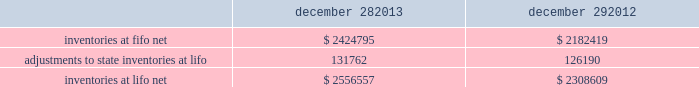Advance auto parts , inc .
And subsidiaries notes to the consolidated financial statements december 28 , 2013 , december 29 , 2012 and december 31 , 2011 ( in thousands , except per share data ) in july 2012 , the fasb issued asu no .
2012-02 201cintangible-goodwill and other 2013 testing indefinite-lived intangible assets for impairment . 201d asu 2012-02 modifies the requirement to test intangible assets that are not subject to amortization based on events or changes in circumstances that might indicate that the asset is impaired now requiring the test only if it is more likely than not that the asset is impaired .
Furthermore , asu 2012-02 provides entities the option of performing a qualitative assessment to determine if it is more likely than not that the fair value of an intangible asset is less than the carrying amount as a basis for determining whether it is necessary to perform a quantitative impairment test .
Asu 2012-02 is effective for fiscal years beginning after september 15 , 2012 and early adoption is permitted .
The adoption of asu 2012-02 had no impact on the company 2019s consolidated financial condition , results of operations or cash flows .
Inventories , net : merchandise inventory the company used the lifo method of accounting for approximately 95% ( 95 % ) of inventories at both december 28 , 2013 and december 29 , 2012 .
Under lifo , the company 2019s cost of sales reflects the costs of the most recently purchased inventories , while the inventory carrying balance represents the costs for inventories purchased in fiscal 2013 and prior years .
The company recorded a reduction to cost of sales of $ 5572 and $ 24087 in fiscal 2013 and fiscal 2012 , respectively .
The company 2019s overall costs to acquire inventory for the same or similar products have generally decreased historically as the company has been able to leverage its continued growth , execution of merchandise strategies and realization of supply chain efficiencies .
In fiscal 2011 , the company recorded an increase to cost of sales of $ 24708 due to an increase in supply chain costs and inflationary pressures affecting certain product categories .
Product cores the remaining inventories are comprised of product cores , the non-consumable portion of certain parts and batteries , which are valued under the first-in , first-out ( 201cfifo 201d ) method .
Product cores are included as part of the company 2019s merchandise costs and are either passed on to the customer or returned to the vendor .
Because product cores are not subject to frequent cost changes like the company 2019s other merchandise inventory , there is no material difference when applying either the lifo or fifo valuation method .
Inventory overhead costs purchasing and warehousing costs included in inventory as of december 28 , 2013 and december 29 , 2012 , were $ 161519 and $ 134258 , respectively .
Inventory balance and inventory reserves inventory balances at the end of fiscal 2013 and 2012 were as follows : december 28 , december 29 .
Inventory quantities are tracked through a perpetual inventory system .
The company completes physical inventories and other targeted inventory counts in its store locations to ensure the accuracy of the perpetual inventory quantities of both merchandise and core inventory in these locations .
In its distribution centers and pdq aes , the company uses a cycle counting program to ensure the accuracy of the perpetual inventory quantities of both merchandise and product core inventory .
Reserves for estimated shrink are established based on the results of physical inventories conducted by the company with the assistance of an independent third party in substantially all of the company 2019s stores over the course of the year , other targeted inventory counts in its stores , results from recent cycle counts in its distribution facilities and historical and current loss trends. .
What was the total reduction to cost of sales from 2011 to 2013? 
Rationale: to find the reduction to cost of sales one must add the total reduction to cost of sales for the 3 years and then subtract the increase in cost of sales for the 3 year period .
Computations: (24708 - (24087 + 5572))
Answer: -4951.0. 